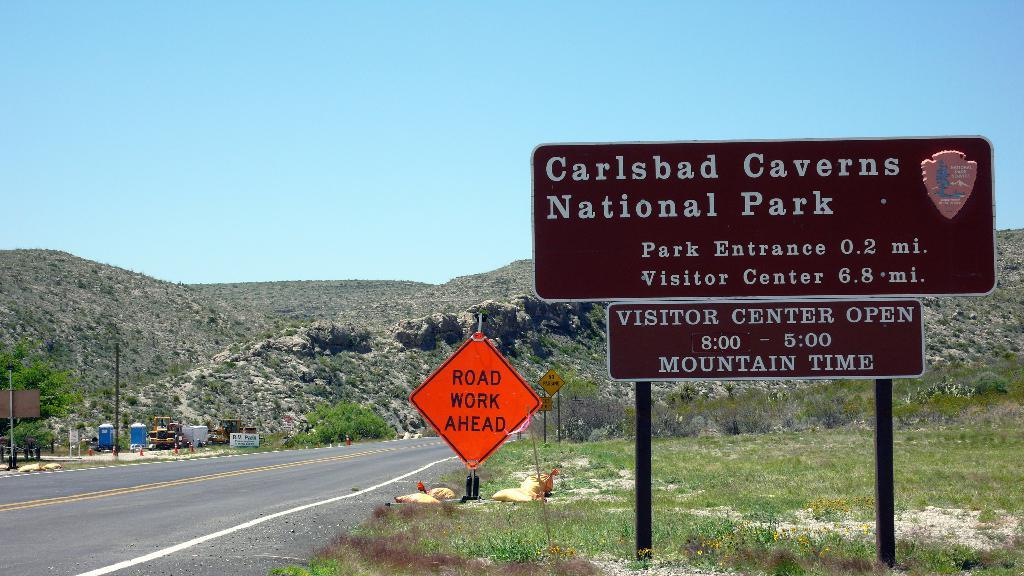<image>
Provide a brief description of the given image. a brown sign that has national park on it 